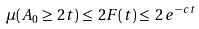Convert formula to latex. <formula><loc_0><loc_0><loc_500><loc_500>\mu ( A _ { 0 } \geq \, 2 t ) \leq \, 2 F ( t ) \leq \, 2 \, e ^ { - c t }</formula> 